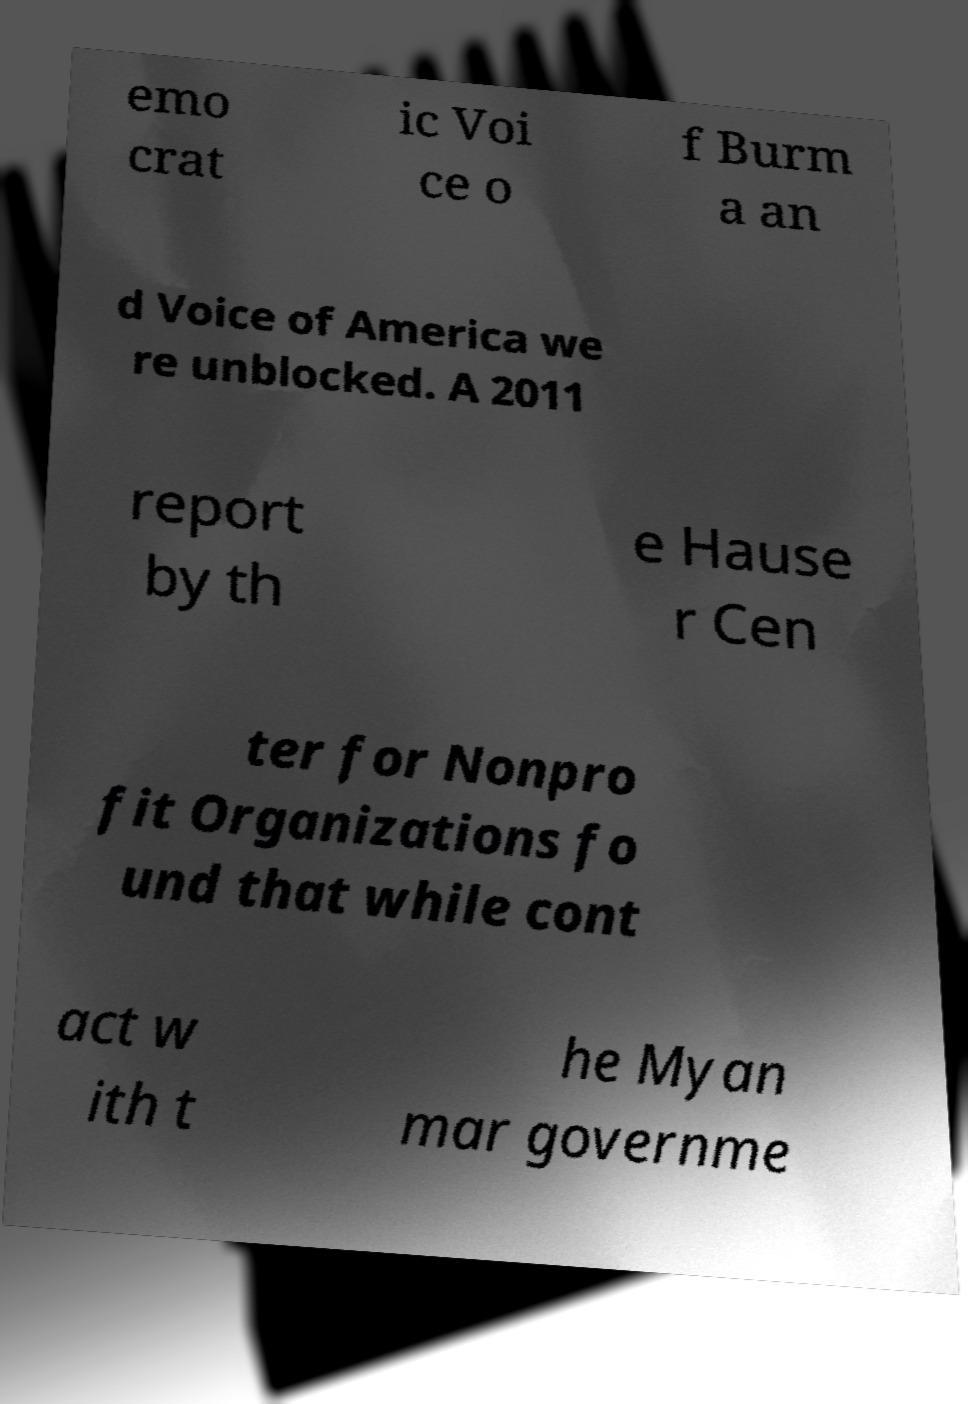Can you read and provide the text displayed in the image?This photo seems to have some interesting text. Can you extract and type it out for me? emo crat ic Voi ce o f Burm a an d Voice of America we re unblocked. A 2011 report by th e Hause r Cen ter for Nonpro fit Organizations fo und that while cont act w ith t he Myan mar governme 